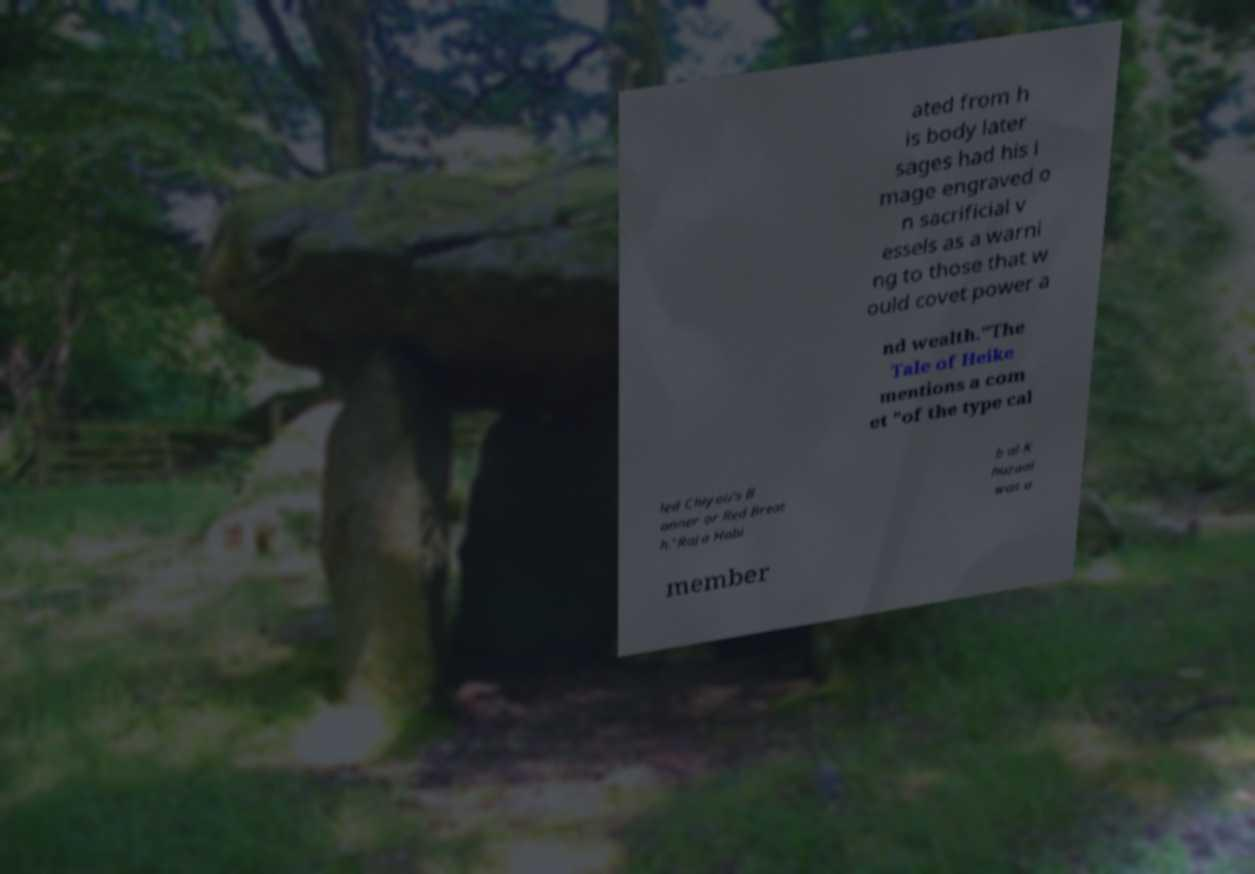Can you accurately transcribe the text from the provided image for me? ated from h is body later sages had his i mage engraved o n sacrificial v essels as a warni ng to those that w ould covet power a nd wealth."The Tale of Heike mentions a com et "of the type cal led Chiyou's B anner or Red Breat h."Raja Habi b al-K huzaai was a member 